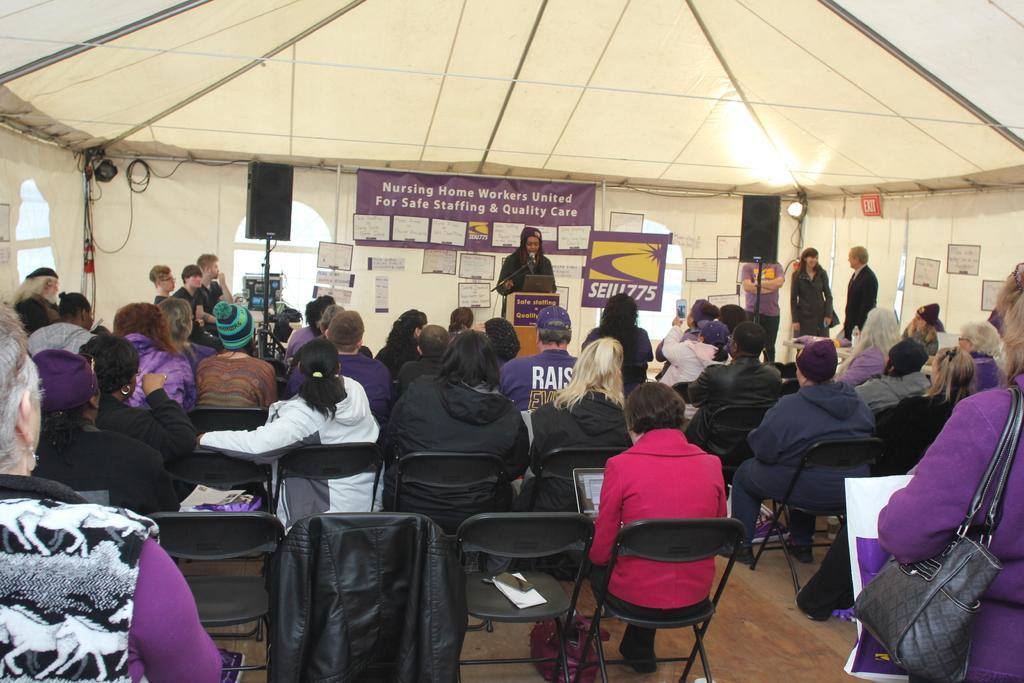Describe this image in one or two sentences. In this image there are group of persons sitting on the chairs at the middle of the image there is a person standing behind the wooden block in front of her there is a microphone and at the right side of the image there are three persons standing and a sound box at the left side of the image there is a sound box. 